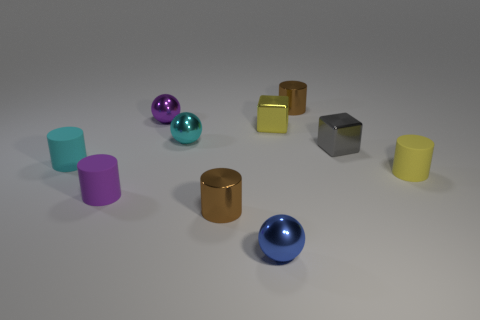Subtract all purple cylinders. How many cylinders are left? 4 Subtract all brown cylinders. How many cylinders are left? 3 Subtract all red cylinders. Subtract all cyan balls. How many cylinders are left? 5 Subtract all blocks. How many objects are left? 8 Add 8 small purple rubber cylinders. How many small purple rubber cylinders are left? 9 Add 7 purple metallic balls. How many purple metallic balls exist? 8 Subtract 1 cyan cylinders. How many objects are left? 9 Subtract all matte things. Subtract all tiny cylinders. How many objects are left? 2 